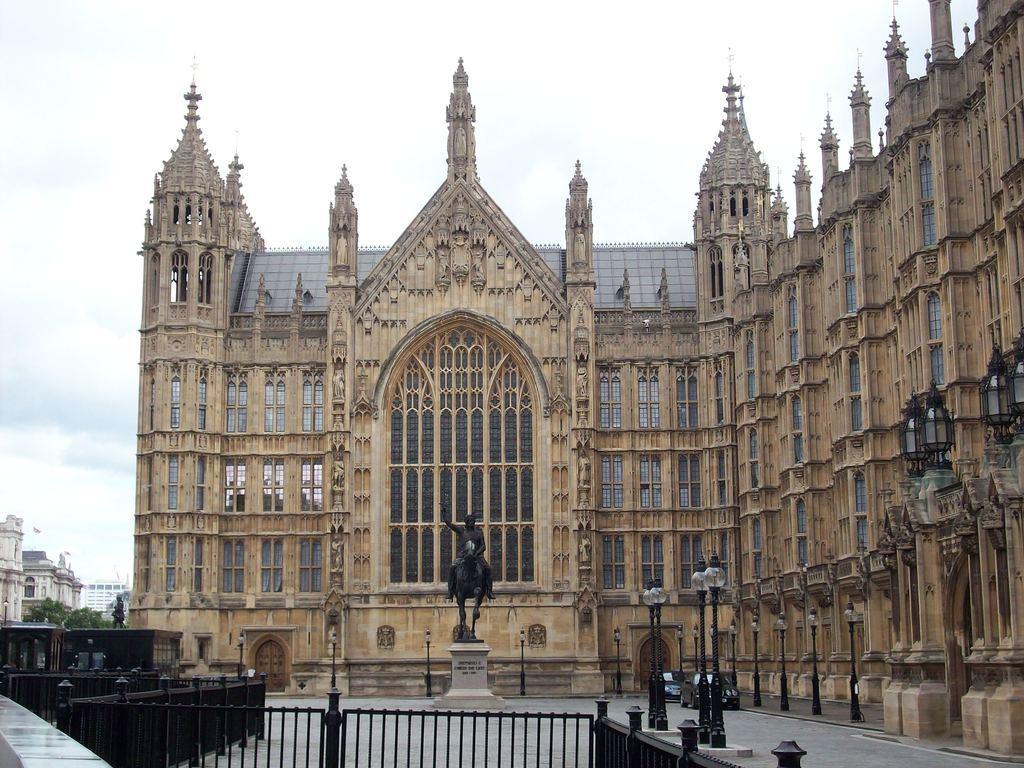How would you summarize this image in a sentence or two? In this image I can see a building. I can see two cars. There are few poles. In the middle of the image I can see a statue. I can see clouds in the sky. 